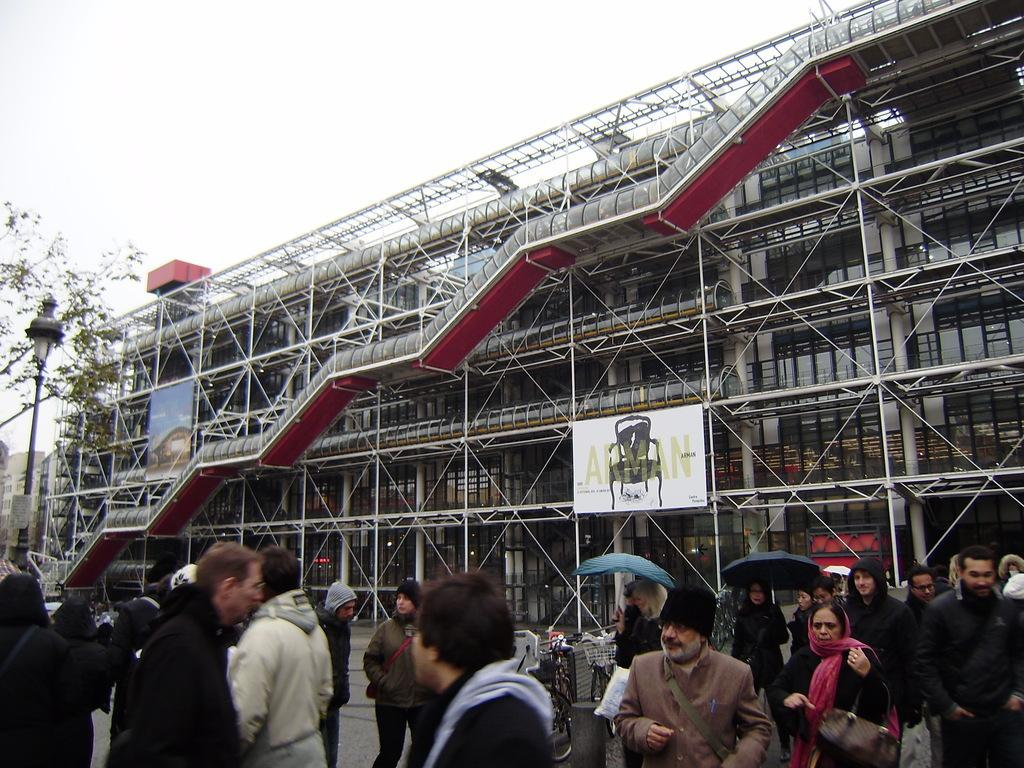How many people can be seen in the image? There is a group of people in the image. What are the people in the image doing? The people are walking on the road. What objects are being used by the people in the image? There are umbrellas in the image. What else can be seen in the image besides the people and umbrellas? Vehicles, boards, a tree, a light, a pole, a building, stairs, and the sky are visible in the image. What type of underwear is visible on the people in the image? There is no underwear visible on the people in the image. What can be seen growing on the straw in the image? There is no straw present in the image. 